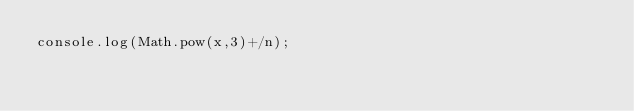Convert code to text. <code><loc_0><loc_0><loc_500><loc_500><_JavaScript_>console.log(Math.pow(x,3)+/n);
</code> 